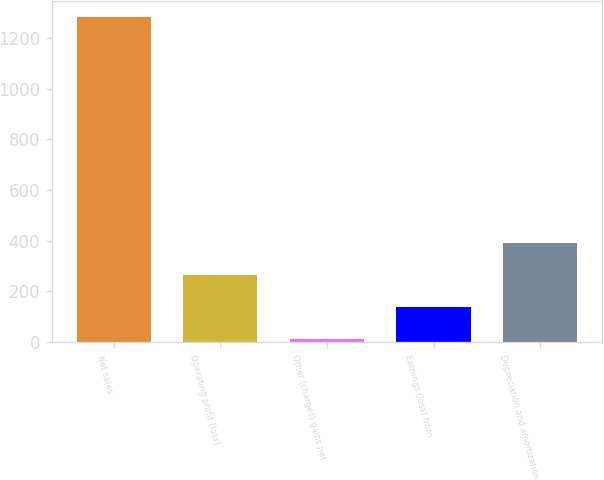<chart> <loc_0><loc_0><loc_500><loc_500><bar_chart><fcel>Net sales<fcel>Operating profit (loss)<fcel>Other (charges) gains net<fcel>Earnings (loss) from<fcel>Depreciation and amortization<nl><fcel>1281<fcel>265<fcel>11<fcel>138<fcel>392<nl></chart> 